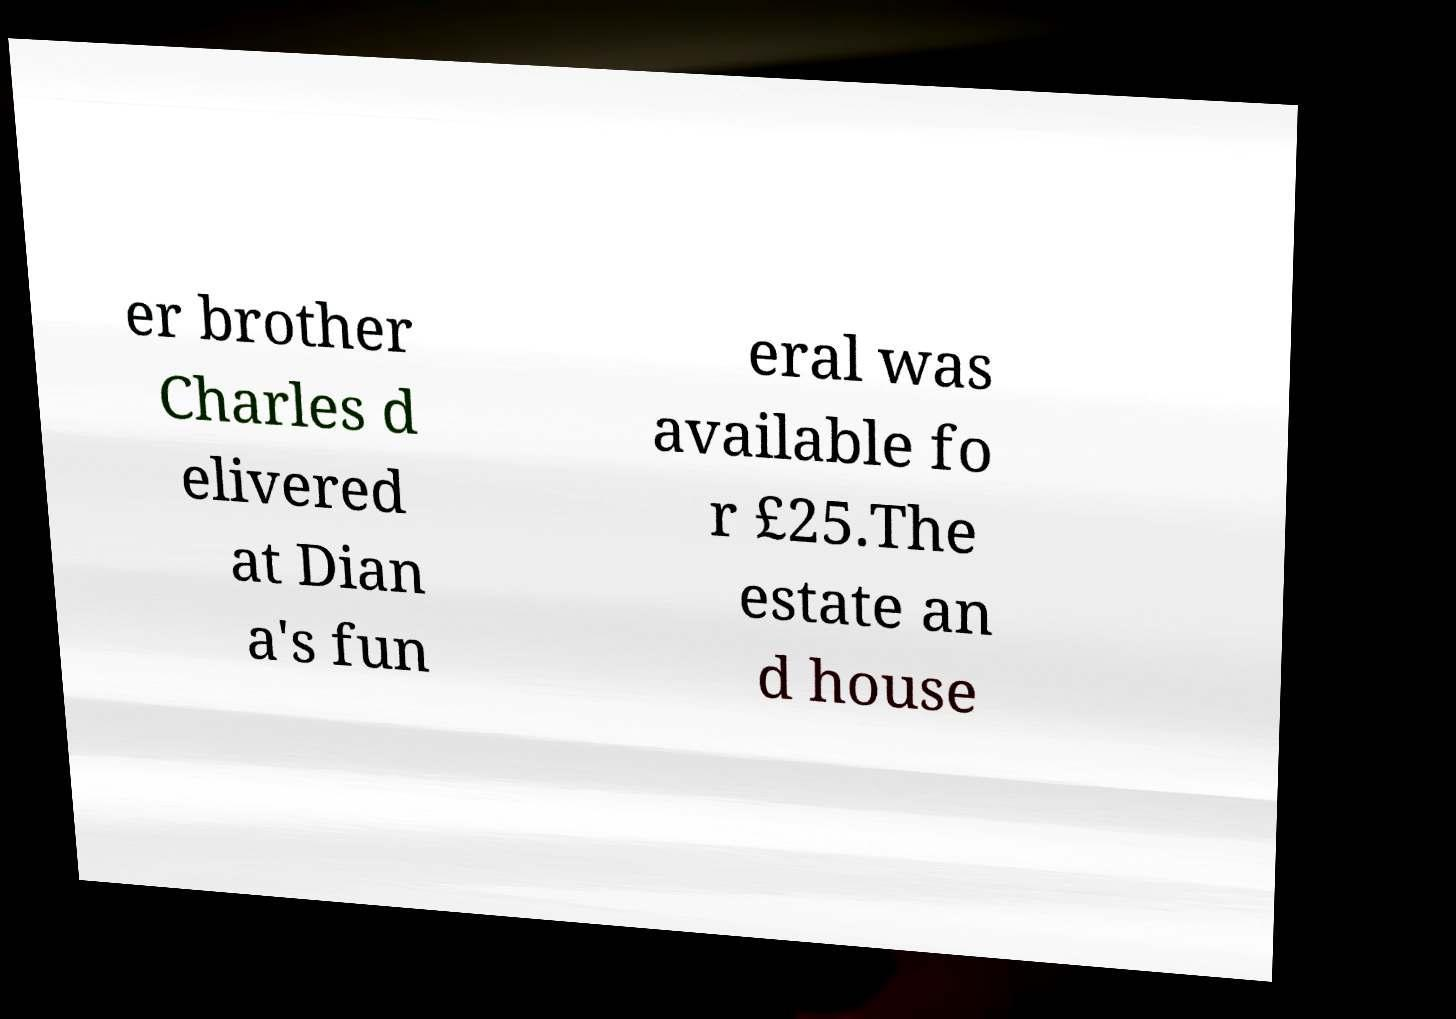Could you assist in decoding the text presented in this image and type it out clearly? er brother Charles d elivered at Dian a's fun eral was available fo r £25.The estate an d house 